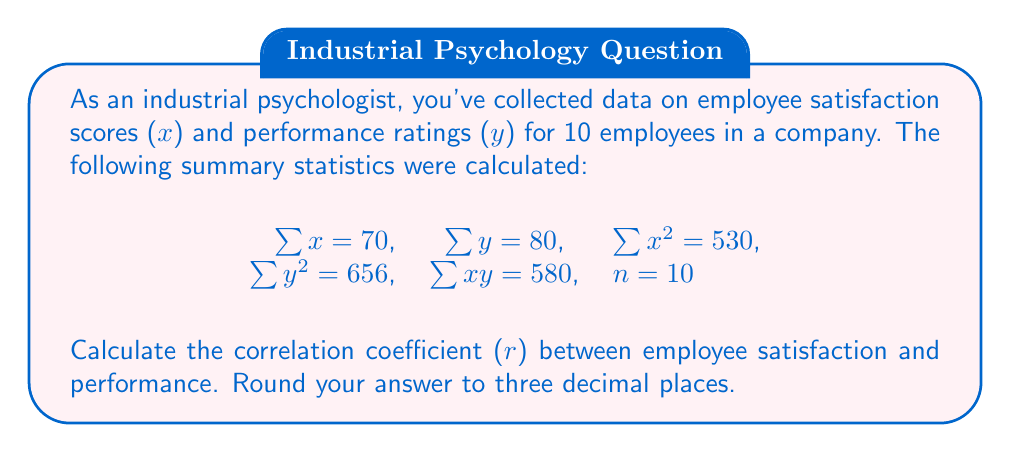What is the answer to this math problem? To calculate the correlation coefficient (r), we'll use the formula:

$$ r = \frac{n\sum xy - \sum x \sum y}{\sqrt{[n\sum x^2 - (\sum x)^2][n\sum y^2 - (\sum y)^2]}} $$

Let's substitute the given values:

$n = 10$
$\sum x = 70$
$\sum y = 80$
$\sum x^2 = 530$
$\sum y^2 = 656$
$\sum xy = 580$

Now, let's calculate step by step:

1) Calculate $n\sum xy$:
   $10 \times 580 = 5800$

2) Calculate $\sum x \sum y$:
   $70 \times 80 = 5600$

3) Calculate the numerator:
   $5800 - 5600 = 200$

4) Calculate $n\sum x^2$:
   $10 \times 530 = 5300$

5) Calculate $(\sum x)^2$:
   $70^2 = 4900$

6) Calculate $n\sum y^2$:
   $10 \times 656 = 6560$

7) Calculate $(\sum y)^2$:
   $80^2 = 6400$

8) Calculate the denominator:
   $\sqrt{(5300 - 4900)(6560 - 6400)} = \sqrt{400 \times 160} = \sqrt{64000} = 252.98$

9) Finally, calculate r:
   $r = \frac{200}{252.98} = 0.7905$

Rounding to three decimal places: $r = 0.791$
Answer: $r = 0.791$ 